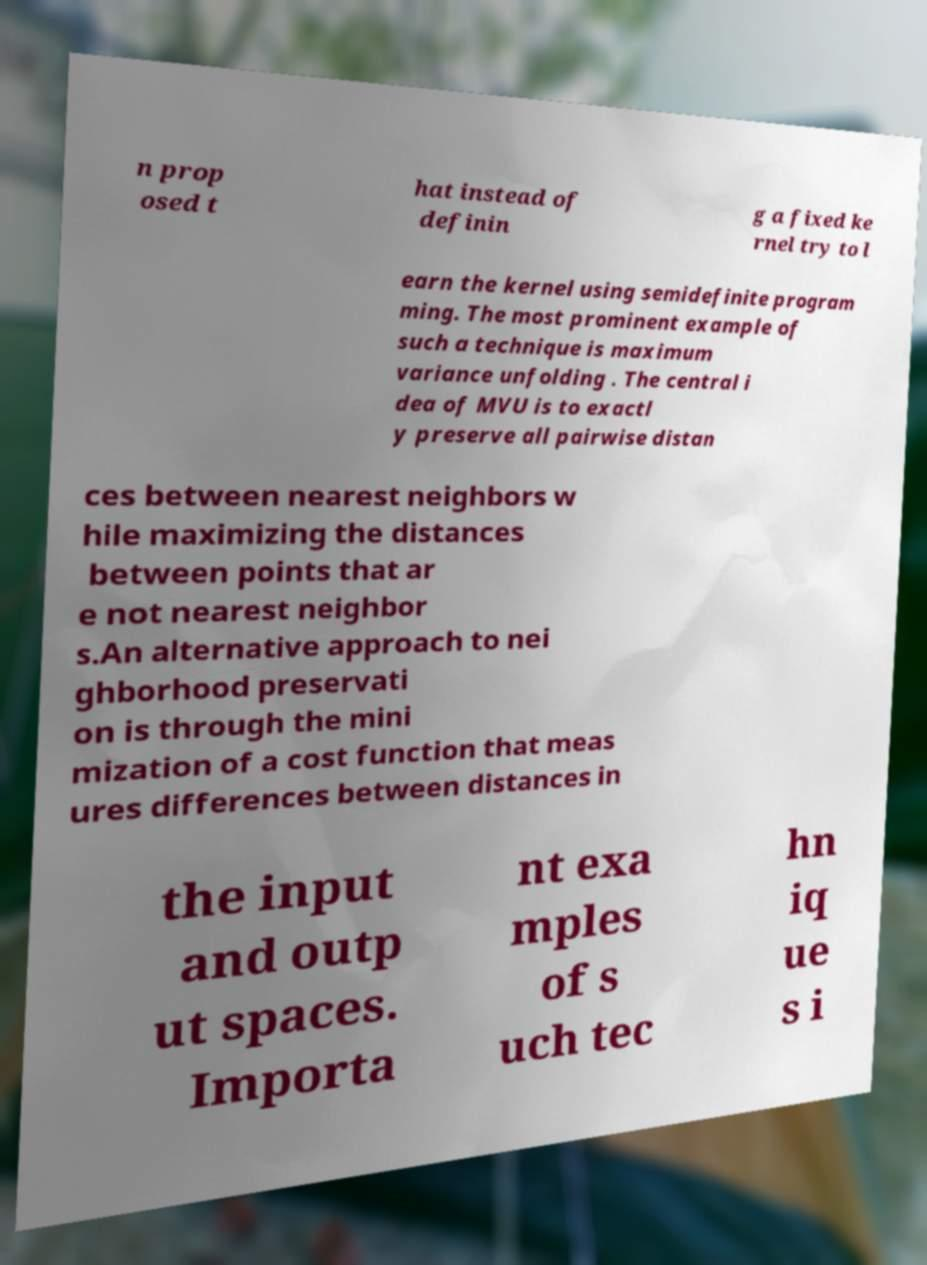There's text embedded in this image that I need extracted. Can you transcribe it verbatim? n prop osed t hat instead of definin g a fixed ke rnel try to l earn the kernel using semidefinite program ming. The most prominent example of such a technique is maximum variance unfolding . The central i dea of MVU is to exactl y preserve all pairwise distan ces between nearest neighbors w hile maximizing the distances between points that ar e not nearest neighbor s.An alternative approach to nei ghborhood preservati on is through the mini mization of a cost function that meas ures differences between distances in the input and outp ut spaces. Importa nt exa mples of s uch tec hn iq ue s i 